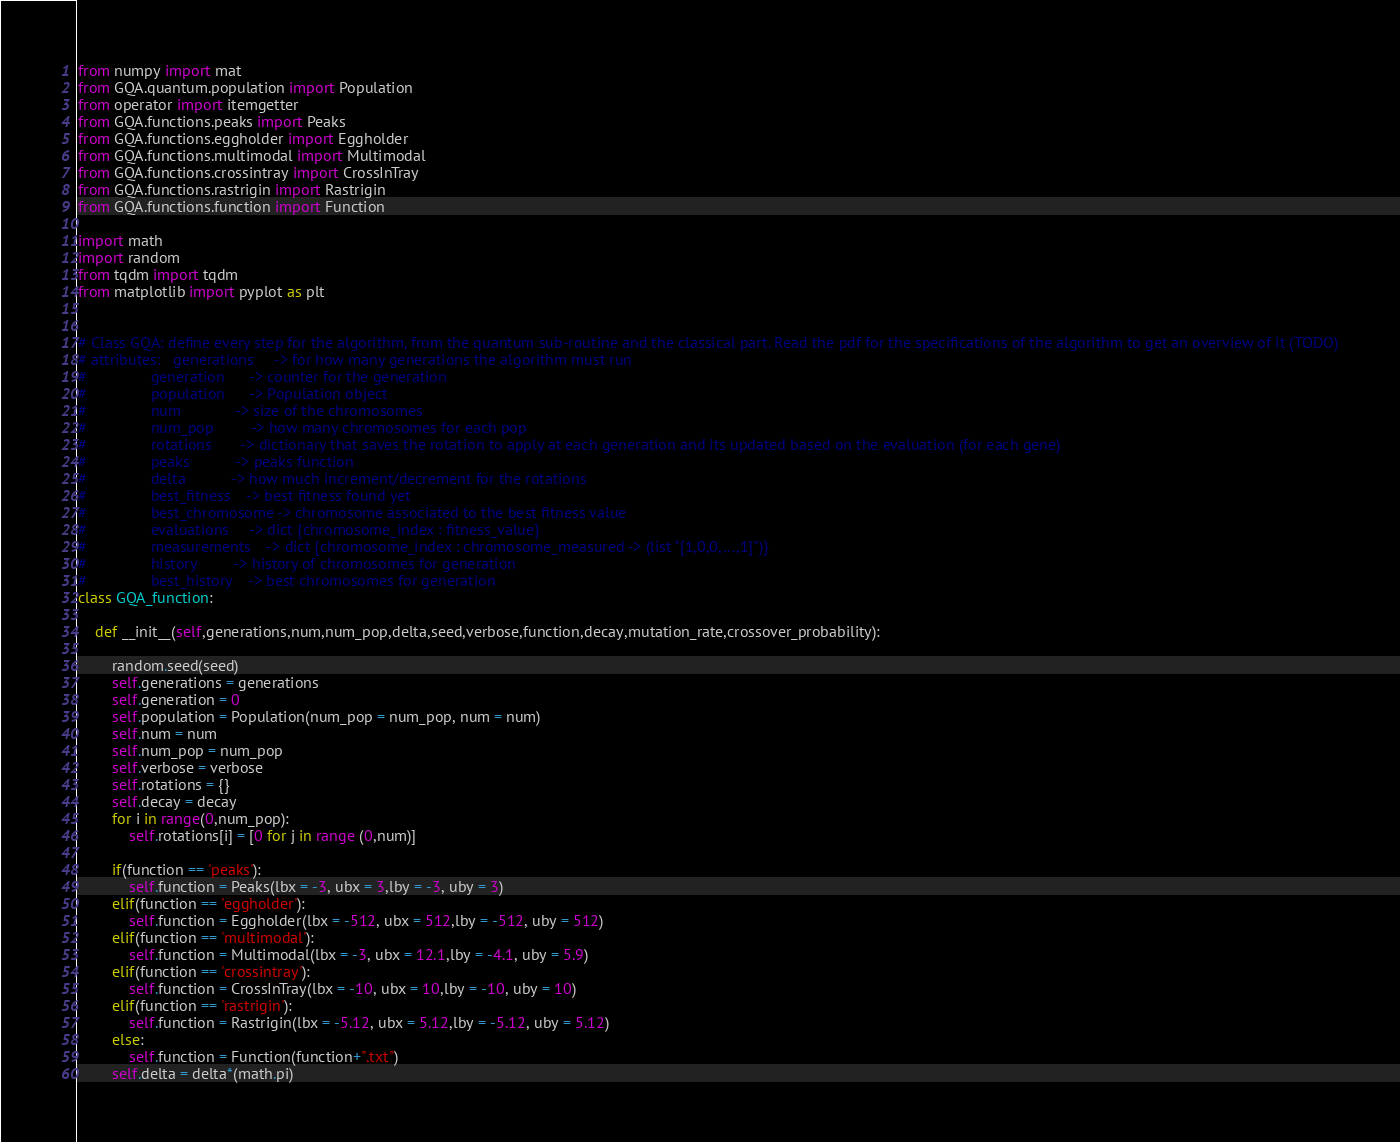<code> <loc_0><loc_0><loc_500><loc_500><_Python_>from numpy import mat
from GQA.quantum.population import Population
from operator import itemgetter
from GQA.functions.peaks import Peaks
from GQA.functions.eggholder import Eggholder
from GQA.functions.multimodal import Multimodal
from GQA.functions.crossintray import CrossInTray
from GQA.functions.rastrigin import Rastrigin
from GQA.functions.function import Function

import math
import random 
from tqdm import tqdm
from matplotlib import pyplot as plt


# Class GQA: define every step for the algorithm, from the quantum sub-routine and the classical part. Read the pdf for the specifications of the algorithm to get an overview of it (TODO)
# attributes:   generations     -> for how many generations the algorithm must run
#               generation      -> counter for the generation
#               population      -> Population object 
#               num             -> size of the chromosomes
#               num_pop         -> how many chromosomes for each pop
#               rotations       -> dictionary that saves the rotation to apply at each generation and its updated based on the evaluation (for each gene)
#               peaks           -> peaks function 
#               delta           -> how much increment/decrement for the rotations
#               best_fitness    -> best fitness found yet
#               best_chromosome -> chromosome associated to the best fitness value 
#               evaluations     -> dict {chromosome_index : fitness_value} 
#               measurements    -> dict {chromosome_index : chromosome_measured -> (list "[1,0,0,...,1]")}
#               history         -> history of chromosomes for generation
#               best_history    -> best chromosomes for generation
class GQA_function:

    def __init__(self,generations,num,num_pop,delta,seed,verbose,function,decay,mutation_rate,crossover_probability):
        
        random.seed(seed)
        self.generations = generations
        self.generation = 0
        self.population = Population(num_pop = num_pop, num = num)
        self.num = num
        self.num_pop = num_pop
        self.verbose = verbose
        self.rotations = {}
        self.decay = decay
        for i in range(0,num_pop):
            self.rotations[i] = [0 for j in range (0,num)]

        if(function == 'peaks'):
            self.function = Peaks(lbx = -3, ubx = 3,lby = -3, uby = 3)
        elif(function == 'eggholder'):
            self.function = Eggholder(lbx = -512, ubx = 512,lby = -512, uby = 512)
        elif(function == 'multimodal'):
            self.function = Multimodal(lbx = -3, ubx = 12.1,lby = -4.1, uby = 5.9)
        elif(function == 'crossintray'):
            self.function = CrossInTray(lbx = -10, ubx = 10,lby = -10, uby = 10)
        elif(function == 'rastrigin'):
            self.function = Rastrigin(lbx = -5.12, ubx = 5.12,lby = -5.12, uby = 5.12)
        else:
            self.function = Function(function+".txt")
        self.delta = delta*(math.pi)</code> 